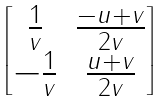<formula> <loc_0><loc_0><loc_500><loc_500>\begin{bmatrix} \frac { 1 } { v } & \frac { - u + v } { 2 v } \\ - \frac { 1 } { v } & \frac { u + v } { 2 v } \end{bmatrix}</formula> 